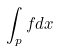Convert formula to latex. <formula><loc_0><loc_0><loc_500><loc_500>\int _ { p } f d x</formula> 